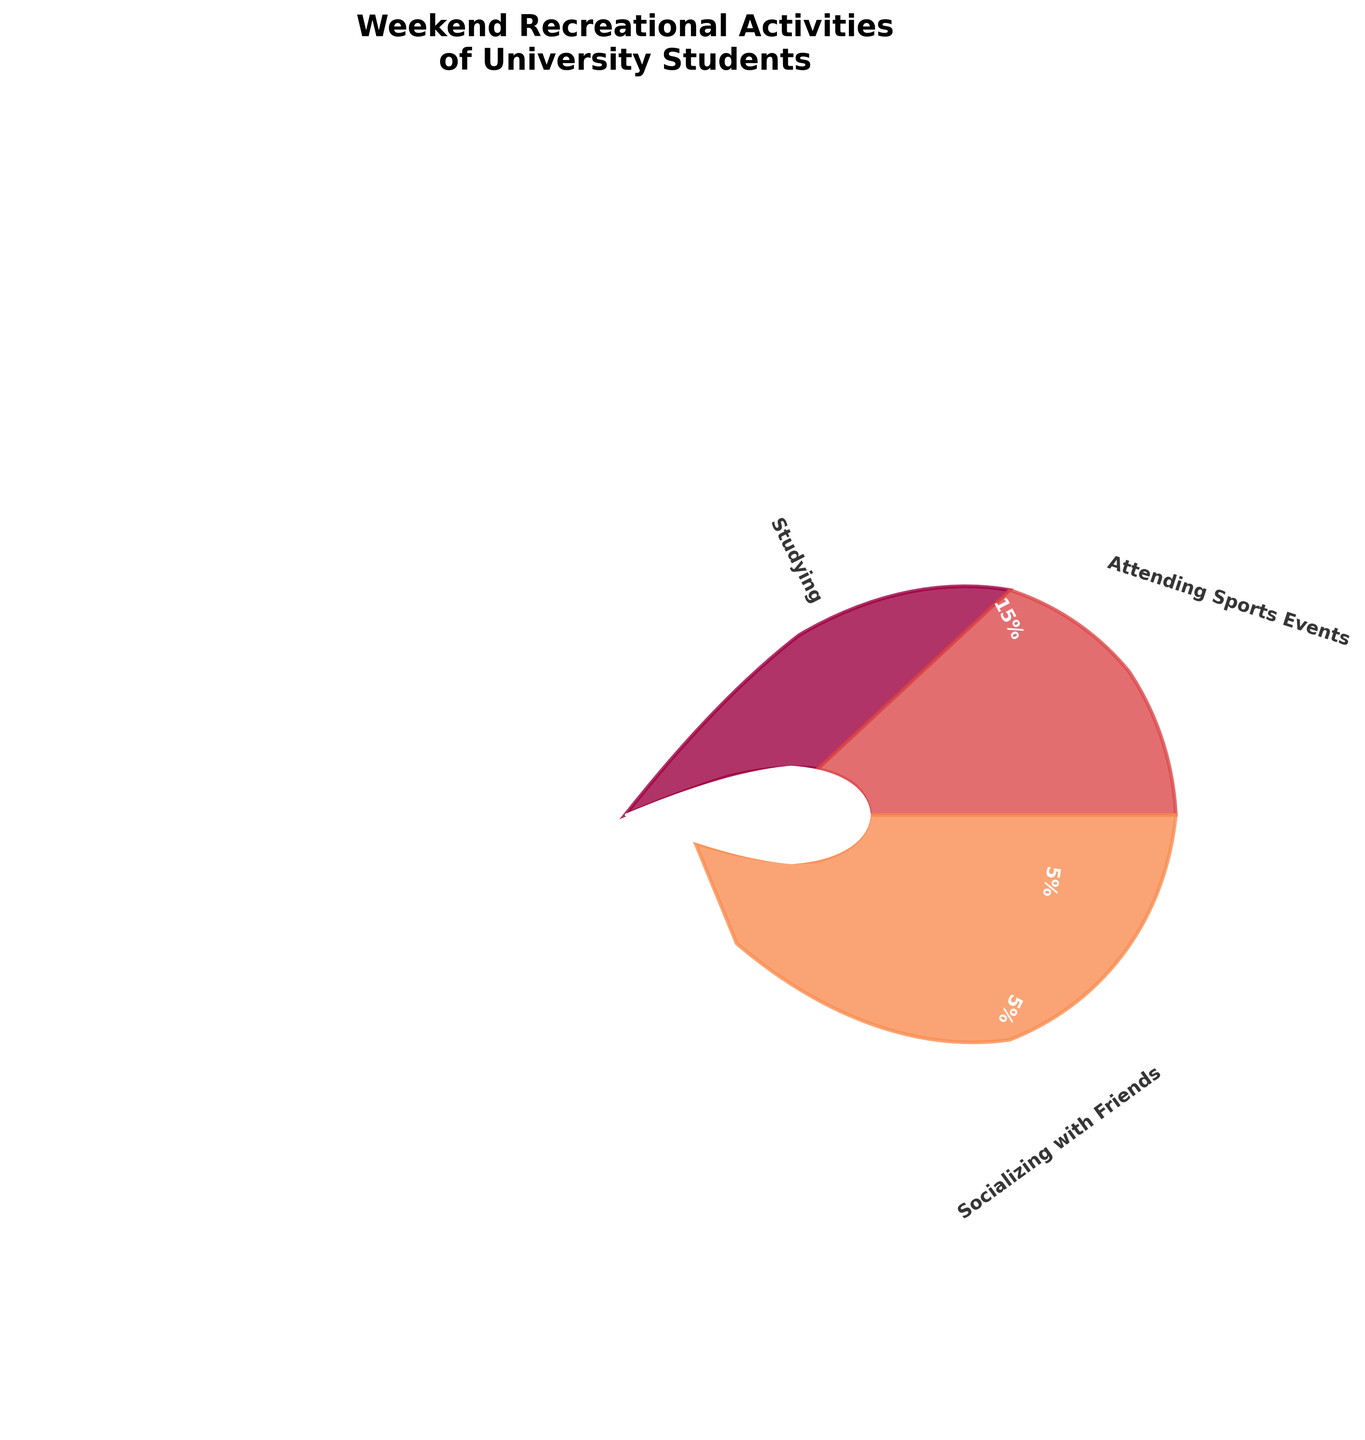What activity has the highest percentage? According to the figure, "Socializing with Friends" has the highest percentage.
Answer: Socializing with Friends Which two activities have the same percentage? From the figure, "Volunteer Work," "Clubbing/Partying," and "Part-time Jobs" all have the same percentage.
Answer: Volunteer Work, Clubbing/Partying, Part-time Jobs What is the total percentage of leisure activities (Socializing with Friends, Watching Movies/TV Shows, Playing Video Games, Clubbing/Partying)? The percentages are 20%, 18%, 12%, and 5%, respectively. Adding these gives 20% + 18% + 12% + 5% = 55%.
Answer: 55% Which activity occupies a larger angle on the plot: "Exercising" or "Playing Video Games"? "Playing Video Games" has a larger percentage with 12%, compared to "Exercising," which has 10%. Hence, "Playing Video Games" occupies a larger angle.
Answer: Playing Video Games What is the difference in percentage between "Studying" and "Attending Sports Events"? The percentage for "Studying" is 15% and for "Attending Sports Events" is 10%. The difference is 15% - 10% = 5%.
Answer: 5% How many activities have less than a 10% share? From the figure, the activities with less than 10% share are "Part-time Jobs," "Volunteer Work," and "Clubbing/Partying," making it a total of three activities.
Answer: 3 What is the average percentage of all activities? There are 9 activities, and their total percentage adds up to 100%. So, the average is 100% / 9 ≈ 11.11%.
Answer: 11.11% Which activities together make up exactly 50%? Looking at the percentages, "Studying" (15%), "Attending Sports Events" (10%), "Exercising" (10%), and "Playing Video Games" (12%) together make 47%. Including "Part-time Jobs" (5%) sums up to exactly 50% (15% + 10% + 10% + 12% + 5% = 50%).
Answer: Studying, Attending Sports Events, Exercising, Playing Video Games, Part-time Jobs What is the percentage difference between the highest and lowest activity? The highest percentage activity is "Socializing with Friends" at 20%, and the lowest is "Volunteer Work," "Clubbing/Partying," and "Part-time Jobs" at 5%. The difference is 20% - 5% = 15%.
Answer: 15% 